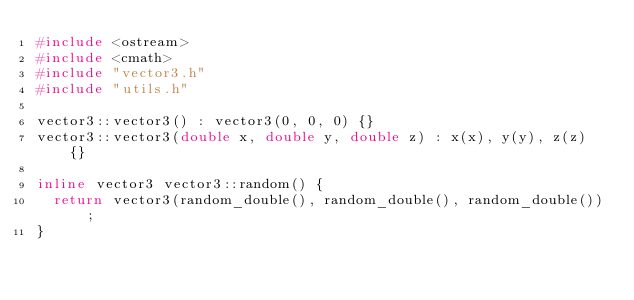Convert code to text. <code><loc_0><loc_0><loc_500><loc_500><_C++_>#include <ostream>
#include <cmath>
#include "vector3.h"
#include "utils.h"

vector3::vector3() : vector3(0, 0, 0) {}
vector3::vector3(double x, double y, double z) : x(x), y(y), z(z) {}

inline vector3 vector3::random() {
	return vector3(random_double(), random_double(), random_double());
}
</code> 